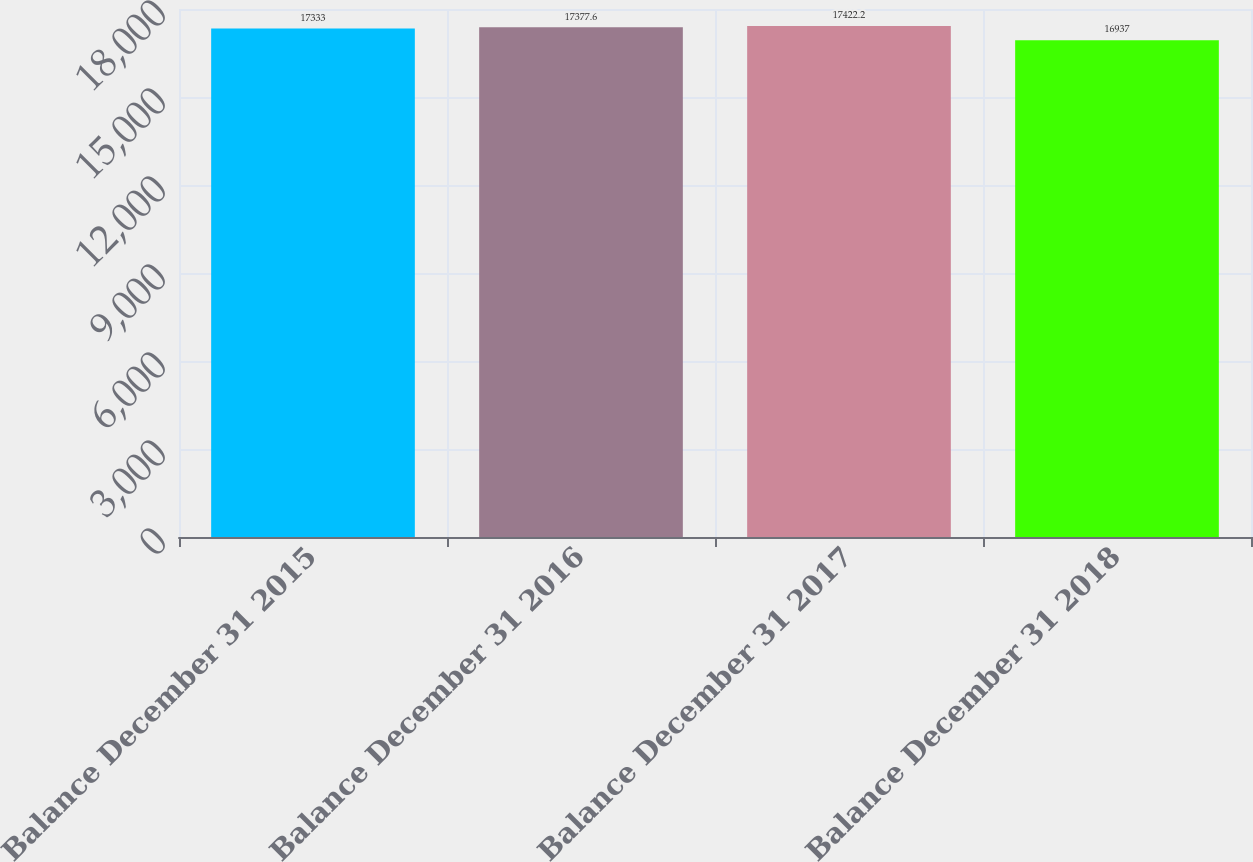<chart> <loc_0><loc_0><loc_500><loc_500><bar_chart><fcel>Balance December 31 2015<fcel>Balance December 31 2016<fcel>Balance December 31 2017<fcel>Balance December 31 2018<nl><fcel>17333<fcel>17377.6<fcel>17422.2<fcel>16937<nl></chart> 